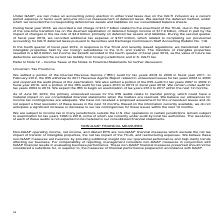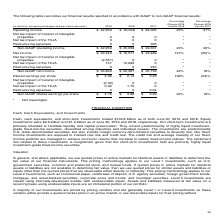According to Microsoft Corporation's financial document, How do these non-GAAP measures aid investors? We believe these non-GAAP measures aid investors by providing additional insight into our operational performance and help clarify trends affecting our business.. The document states: "ax impact of the TCJA, and restructuring expenses. We believe these non-GAAP measures aid investors by providing additional insight into our operation..." Also, Why does management consider non-GAAP measures in conjunction with GAAP financial results? management considers non-GAAP measures in conjunction with GAAP financial results in evaluating business performance.. The document states: "ting our business. For comparability of reporting, management considers non-GAAP measures in conjunction with GAAP financial results in evaluating bus..." Also, Which non-GAAP measures exclude the net tax impact of transfer of intangible properties, the net tax impact of the TCJA and restructuring expenses? Non-GAAP operating income, net income, and diluted EPS are non-GAAP financial measures which exclude the net tax impact of transfer of intangible properties, the net tax impact of the TCJA, and restructuring expenses.. The document states: "Non-GAAP operating income, net income, and diluted EPS are non-GAAP financial measures which exclude the net tax impact of transfer of intangible prop..." Also, can you calculate: What was the average operating income for the 3 year period from 2017 to 2019? To answer this question, I need to perform calculations using the financial data. The calculation is: (42,959 + 35,058+29,025)/(2019-2017+1), which equals 35680.67 (in millions). This is based on the information: "Operating income $ 42,959 $ 35,058 $ 29,025 23% 21% Operating income $ 42,959 $ 35,058 $ 29,025 23% 21% Operating income $ 42,959 $ 35,058 $ 29,025 23% 21%..." The key data points involved are: 29,025, 35,058, 42,959. Also, can you calculate: What is the average non-GAAP net income for the 3 year period from 2017 to 2019? To answer this question, I need to perform calculations using the financial data. The calculation is: (36,830+30,267+25,732)/(2019-2017+1), which equals 30943 (in millions). This is based on the information: "Non-GAAP net income $ 36,830 $ 30,267 $ 25,732 22% 18% Non-GAAP net income $ 36,830 $ 30,267 $ 25,732 22% 18% Non-GAAP net income $ 36,830 $ 30,267 $ 25,732 22% 18%..." The key data points involved are: 25,732, 30,267, 36,830. Also, can you calculate: What is the percentage change in operating income from 2017 to 2019? To answer this question, I need to perform calculations using the financial data. The calculation is: (42,959-29,025)/29,025, which equals 48.01 (percentage). This is based on the information: "Operating income $ 42,959 $ 35,058 $ 29,025 23% 21% Operating income $ 42,959 $ 35,058 $ 29,025 23% 21%..." The key data points involved are: 29,025, 42,959. 